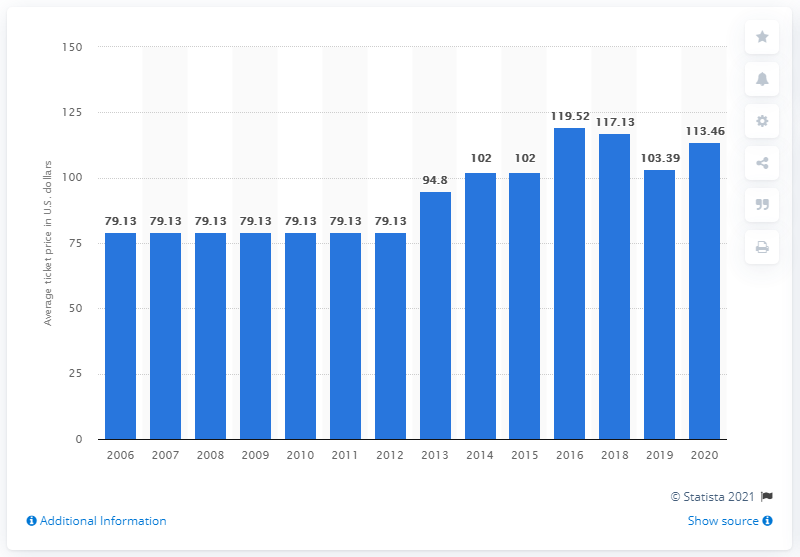Mention a couple of crucial points in this snapshot. The average ticket price for Washington Football Team games in 2020 was $113.46. 